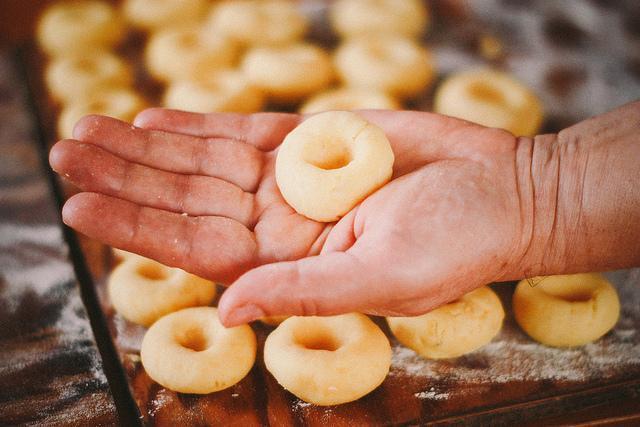How many cakes on in her hand?
Give a very brief answer. 1. How many donuts are there?
Give a very brief answer. 12. How many elephants are here?
Give a very brief answer. 0. 